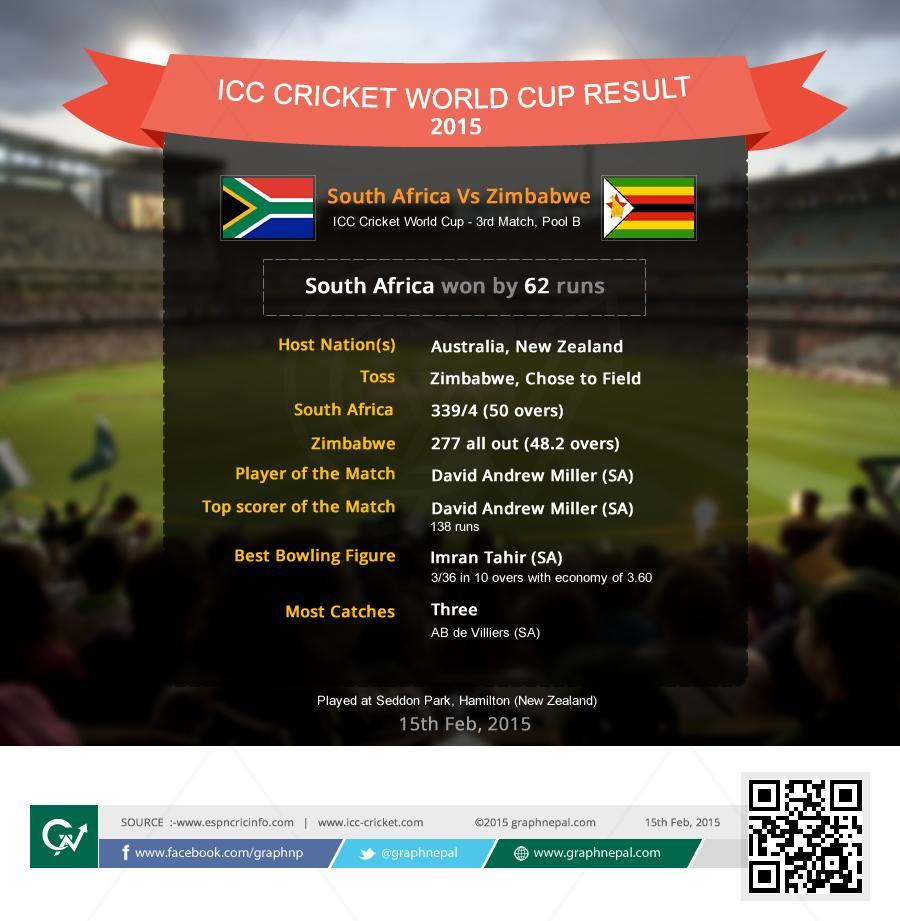How many Wickets of South Africa were gone?
Answer the question with a short phrase. 4 How many Wickets of Zimbabwe were gone? 10 How many wickets were taken by Imran Tahir? 3 What is the score of South Africa? 339/4 How many runs were given by Imran Tahir? 36 